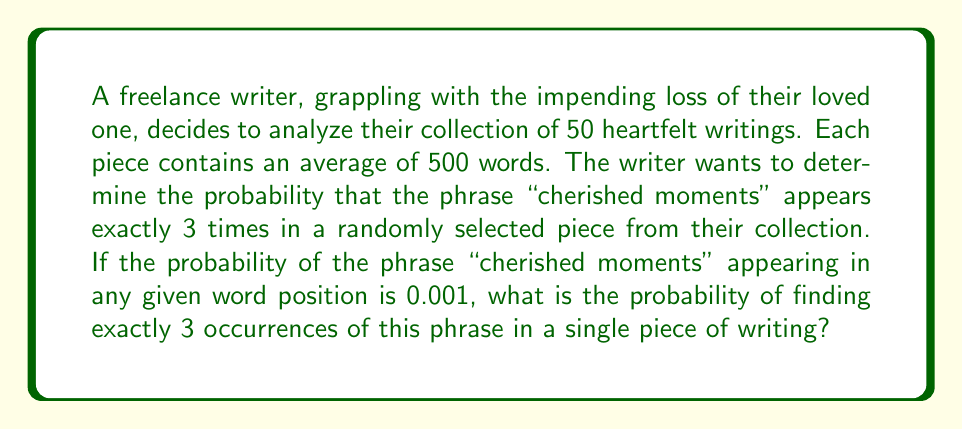Show me your answer to this math problem. To solve this problem, we can use the Poisson distribution, which is appropriate for rare events occurring in a fixed interval. In this case, our event is the occurrence of the phrase "cherished moments" in a piece of writing.

1. Calculate the expected number of occurrences (λ):
   λ = (number of words) × (probability per word)
   λ = 500 × 0.001 = 0.5

2. Use the Poisson probability mass function:
   $$P(X = k) = \frac{e^{-λ} λ^k}{k!}$$
   Where:
   - e is Euler's number (approximately 2.71828)
   - λ is the expected number of occurrences
   - k is the number of occurrences we're interested in (3 in this case)

3. Plug in the values:
   $$P(X = 3) = \frac{e^{-0.5} (0.5)^3}{3!}$$

4. Calculate step by step:
   $$P(X = 3) = \frac{0.6065 \times 0.125}{6}$$
   $$P(X = 3) = \frac{0.0758125}{6}$$
   $$P(X = 3) = 0.01263541667$$

5. Round to 4 decimal places:
   P(X = 3) ≈ 0.0126
Answer: The probability of finding exactly 3 occurrences of the phrase "cherished moments" in a randomly selected piece of writing is approximately 0.0126 or 1.26%. 